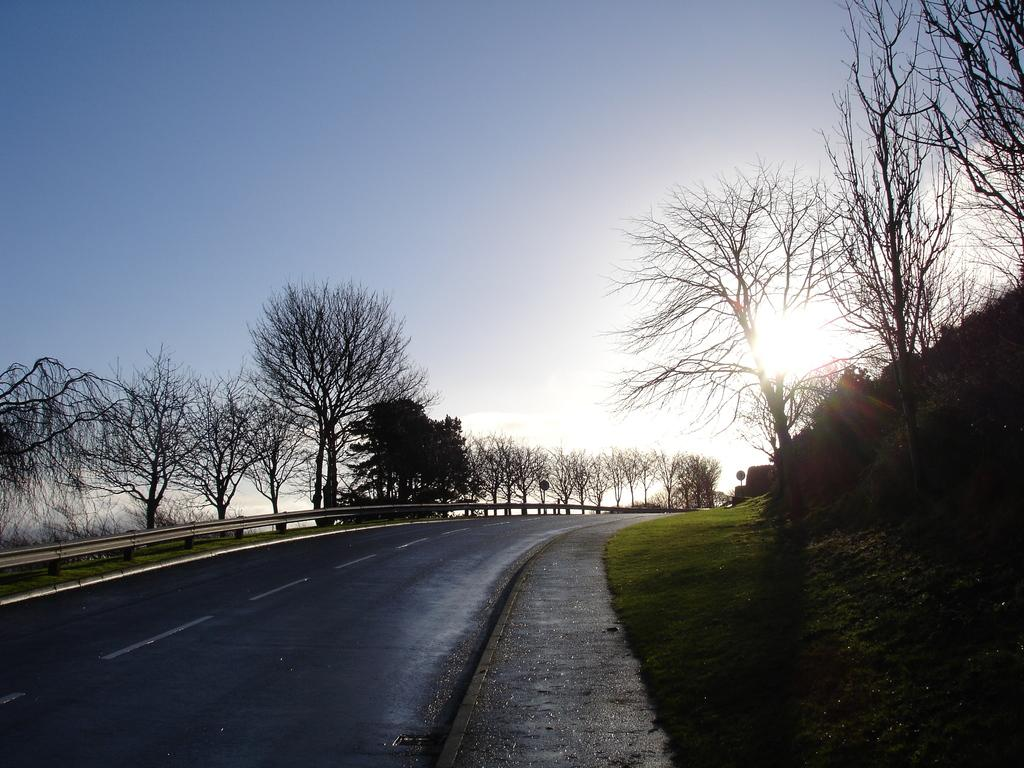What type of pathway is visible in the image? There is a road in the image. What type of barrier is present alongside the road? There is railing in the image. What type of vegetation can be seen near the road? There is grass in the image. What type of tall plants are present in the image? There are trees in the image. What is visible above the road and trees in the image? The sky is visible in the image. Can you tell me how many chess pieces are on the back of the vessel in the image? There is no vessel or chess pieces present in the image. What type of creature is shown interacting with the railing on the road in the image? There is no creature shown interacting with the railing on the road in the image; only the road, railing, grass, trees, and sky are present. 